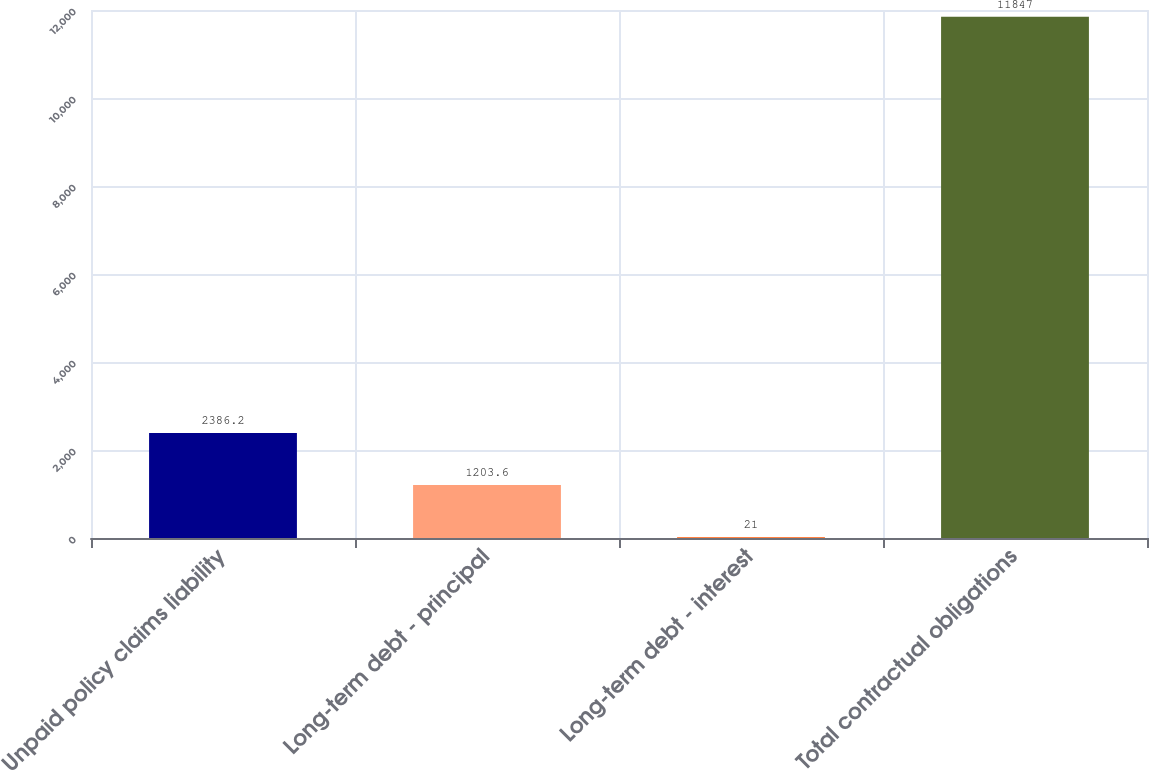Convert chart. <chart><loc_0><loc_0><loc_500><loc_500><bar_chart><fcel>Unpaid policy claims liability<fcel>Long-term debt - principal<fcel>Long-term debt - interest<fcel>Total contractual obligations<nl><fcel>2386.2<fcel>1203.6<fcel>21<fcel>11847<nl></chart> 